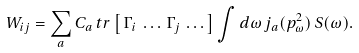Convert formula to latex. <formula><loc_0><loc_0><loc_500><loc_500>W _ { i j } = \sum _ { a } C _ { a } \, t r \left [ \, \Gamma _ { i } \, \dots \, \Gamma _ { j } \, \dots \right ] \int d \omega \, j _ { a } ( p _ { \omega } ^ { 2 } ) \, S ( \omega ) .</formula> 